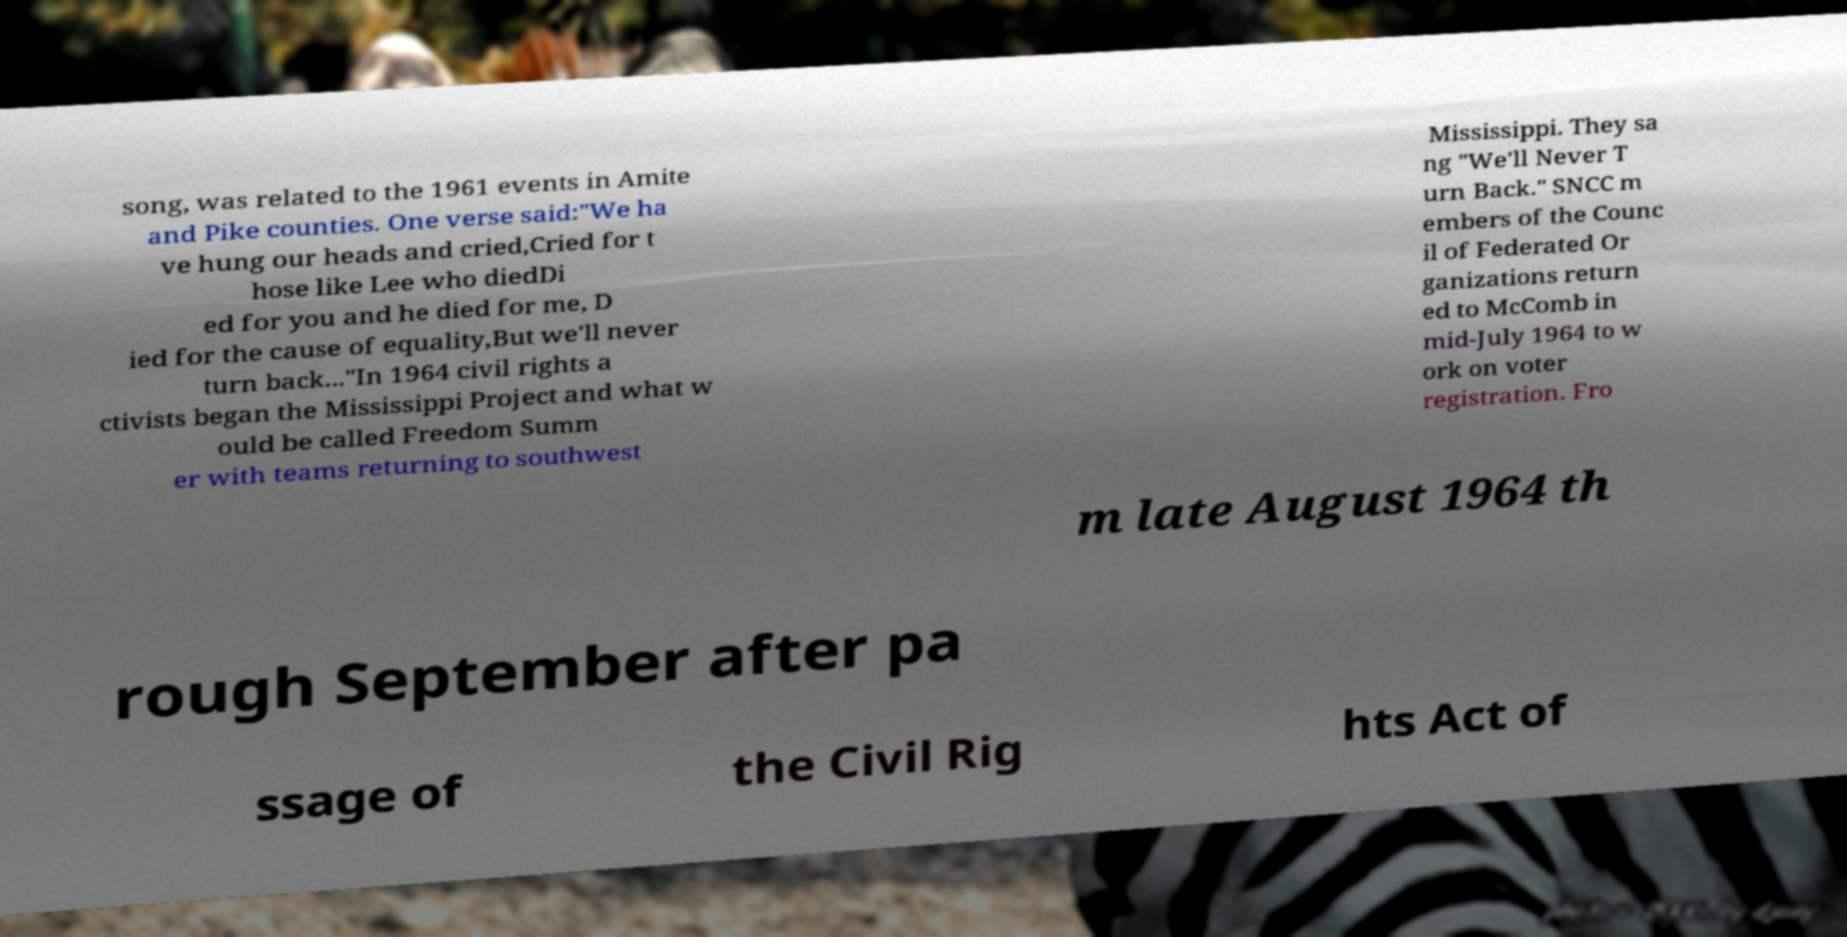Could you extract and type out the text from this image? song, was related to the 1961 events in Amite and Pike counties. One verse said:"We ha ve hung our heads and cried,Cried for t hose like Lee who diedDi ed for you and he died for me, D ied for the cause of equality,But we'll never turn back..."In 1964 civil rights a ctivists began the Mississippi Project and what w ould be called Freedom Summ er with teams returning to southwest Mississippi. They sa ng "We'll Never T urn Back." SNCC m embers of the Counc il of Federated Or ganizations return ed to McComb in mid-July 1964 to w ork on voter registration. Fro m late August 1964 th rough September after pa ssage of the Civil Rig hts Act of 